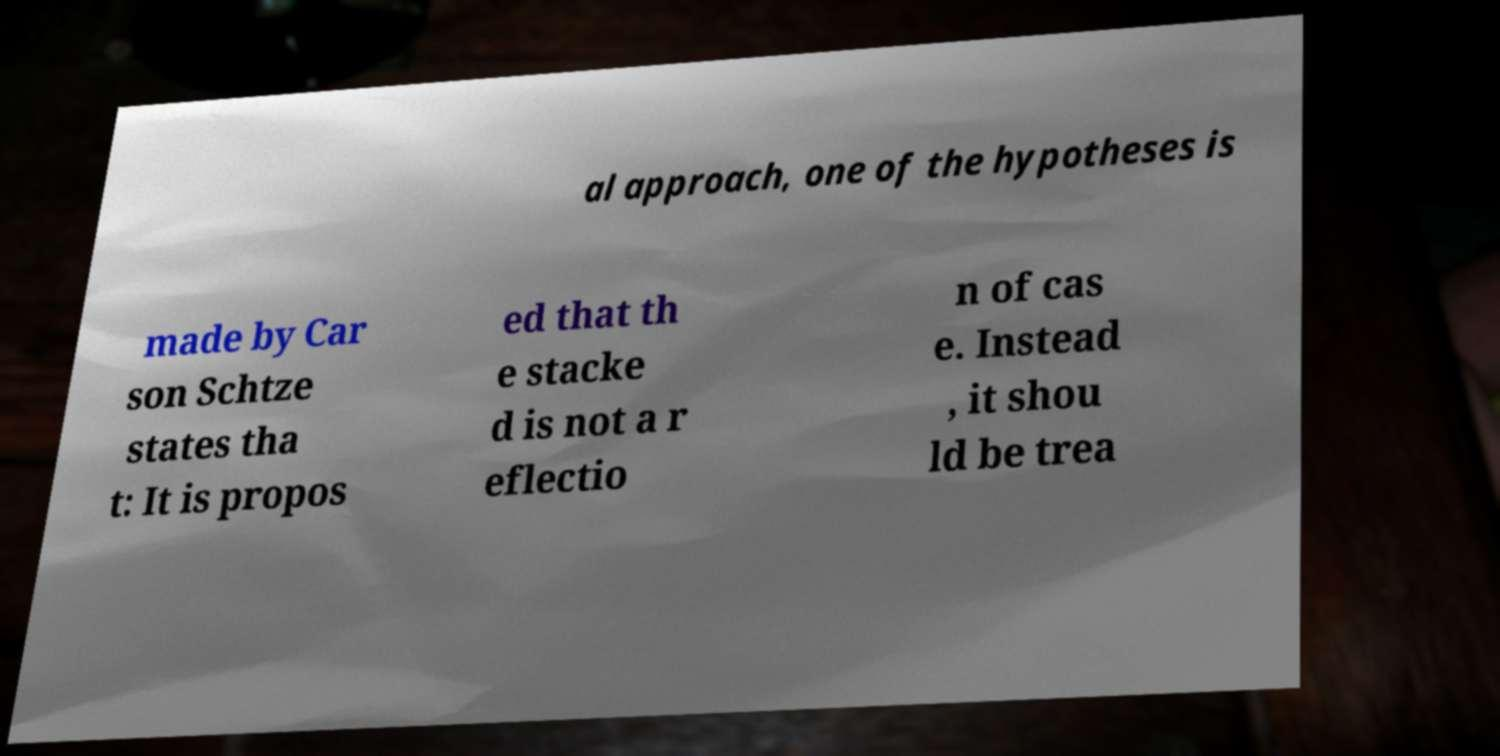There's text embedded in this image that I need extracted. Can you transcribe it verbatim? al approach, one of the hypotheses is made by Car son Schtze states tha t: It is propos ed that th e stacke d is not a r eflectio n of cas e. Instead , it shou ld be trea 